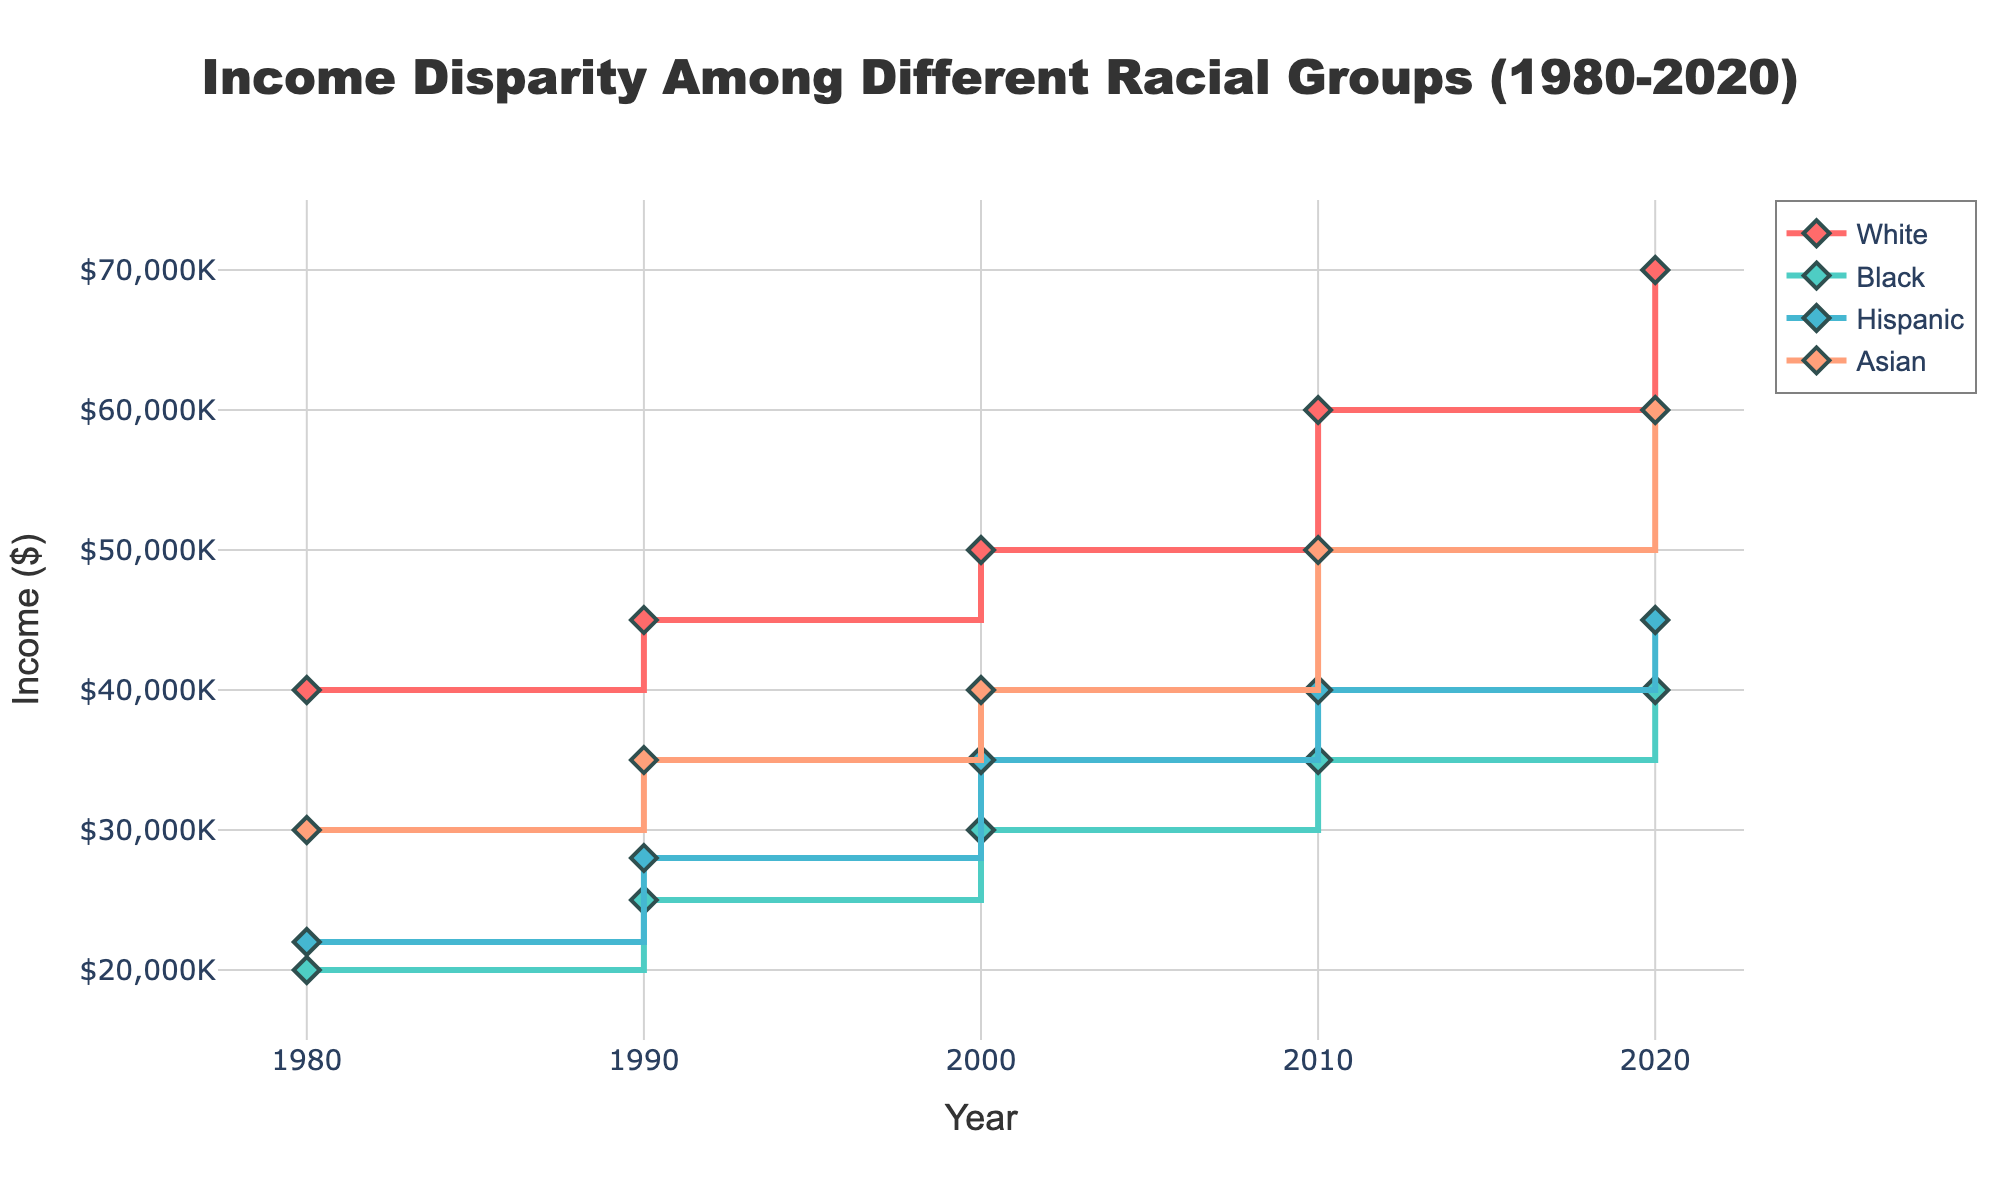what is the title of the figure? The title is typically displayed at the top of the figure. It summarizes the main content of the plot.
Answer: Income Disparity Among Different Racial Groups (1980-2020) What is the income of Black individuals in 2000? Locate the year 2000 on the x-axis and find the corresponding income value for the Black group, marked in the figure.
Answer: $30,000 What is the difference in income between White and Hispanic groups in 2010? Locate the year 2010 on the x-axis, then find the income values for the White and Hispanic groups and subtract the Hispanic income from the White income.
Answer: $20,000 Which group had the highest income in 2020? Locate the year 2020 on the x-axis, then check the income values for all groups and identify the highest value.
Answer: White What pattern do you observe in the income trend for Asian individuals from 1980 to 2020? Examine the plotted data points for the Asian group across the years and describe the overall direction and changes.
Answer: Increasing trend Which group had the smallest income disparity between 1980 and 2020? Calculate the difference between income values in 1980 and 2020 for each group and identify the smallest difference.
Answer: Black What is the average income for Hispanic individuals across all the recorded years? Sum the income values for the Hispanic group over all years and divide by the number of years sampled (5).
Answer: $34,000 Between 1990 and 2020, which group showed the steepest increase in income? Determine the slope of income change for each group by comparing the differences in income from 1990 to 2020 and identify the steepest one.
Answer: Asian How does the income of Black individuals in 1990 compare to that of Hispanic individuals in 2000? Find and compare the income values for Black individuals in 1990 and Hispanic individuals in 2000.
Answer: Black individuals in 1990 had $5,000 less income Based on the stair plot, which group consistently had higher incomes than the Hispanic group in all recorded years? Review the income values across all years and compare each group to the Hispanic group's income.
Answer: White and Asian 